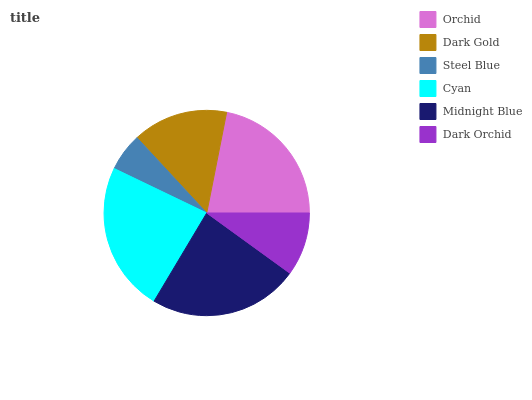Is Steel Blue the minimum?
Answer yes or no. Yes. Is Midnight Blue the maximum?
Answer yes or no. Yes. Is Dark Gold the minimum?
Answer yes or no. No. Is Dark Gold the maximum?
Answer yes or no. No. Is Orchid greater than Dark Gold?
Answer yes or no. Yes. Is Dark Gold less than Orchid?
Answer yes or no. Yes. Is Dark Gold greater than Orchid?
Answer yes or no. No. Is Orchid less than Dark Gold?
Answer yes or no. No. Is Orchid the high median?
Answer yes or no. Yes. Is Dark Gold the low median?
Answer yes or no. Yes. Is Dark Orchid the high median?
Answer yes or no. No. Is Dark Orchid the low median?
Answer yes or no. No. 